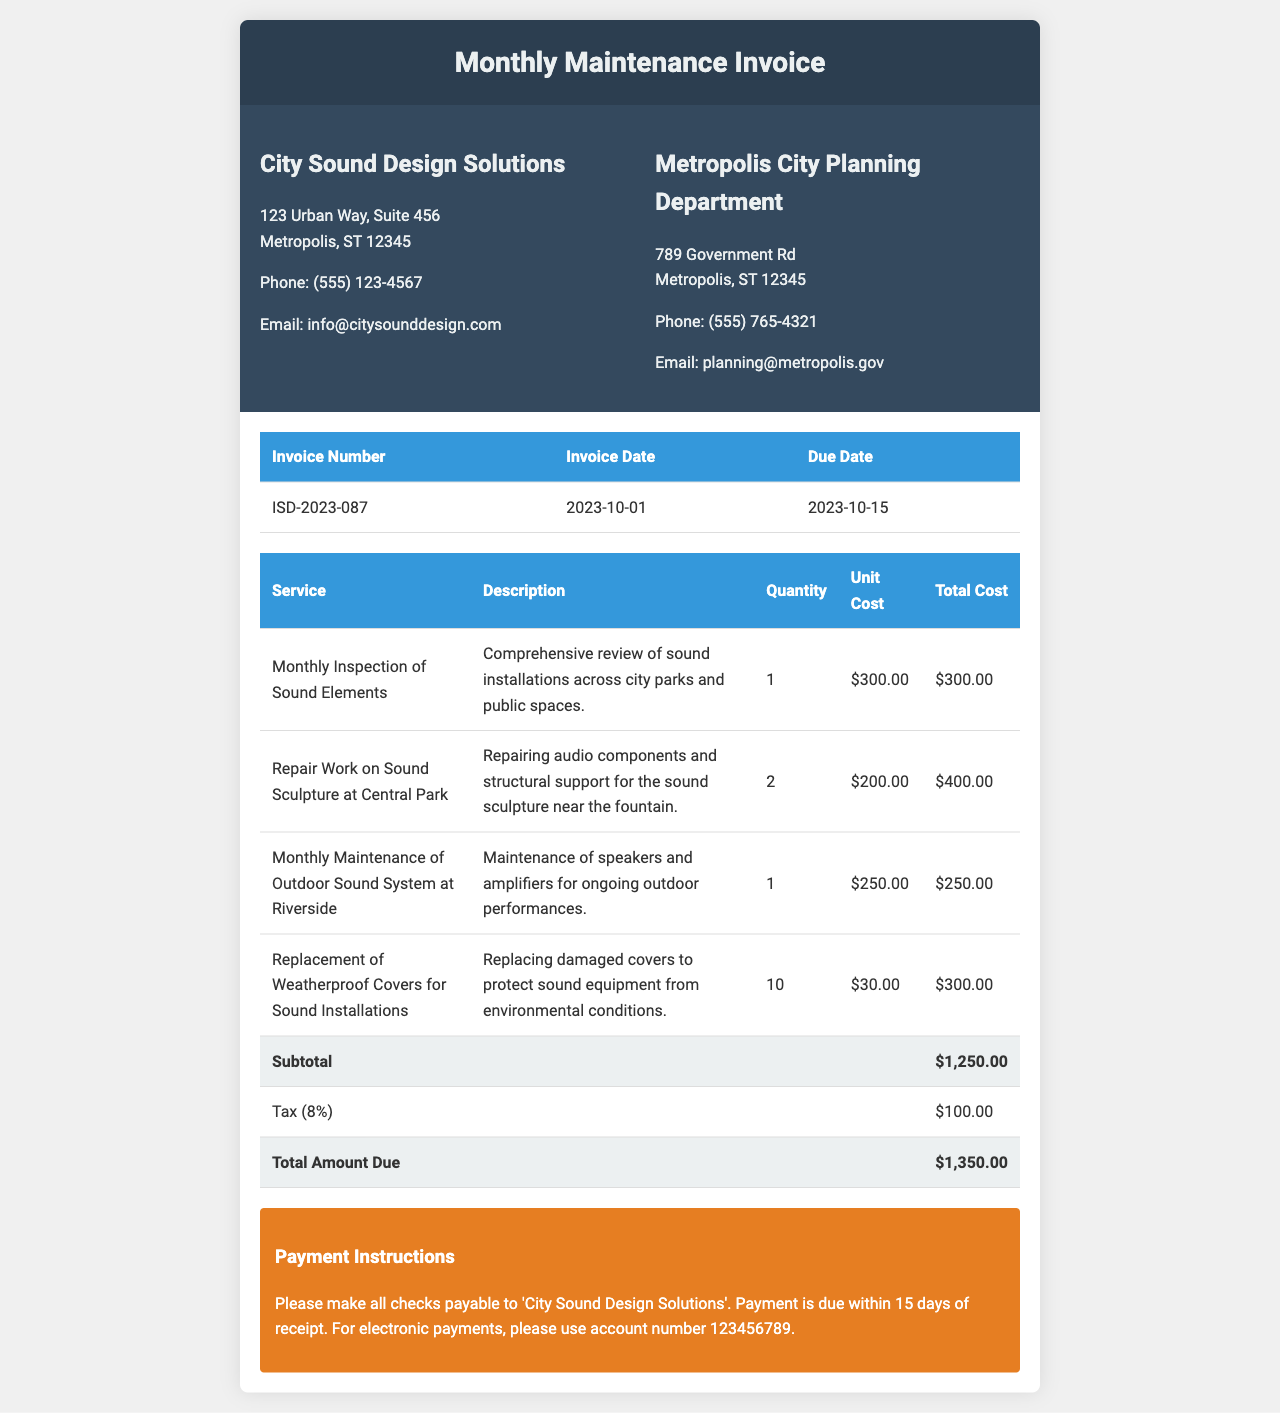What is the invoice number? The invoice number is provided in the document under the Invoice Details section.
Answer: ISD-2023-087 What is the total amount due? The total amount due can be found at the bottom of the invoice table in the Total Amount Due row.
Answer: $1,350.00 What is the due date for payment? The due date is mentioned under the Invoice Details section of the document.
Answer: 2023-10-15 How many weatherproof covers were replaced? The quantity for weatherproof covers is listed in the service table.
Answer: 10 What is the unit cost for the monthly inspection of sound elements? The unit cost can be found in the service table against the respective service description.
Answer: $300.00 How many services are listed in the invoice? The number of services can be determined by counting the rows in the service table, excluding the header.
Answer: 4 What is the tax percentage applied to the invoice? The tax percentage is noted in the service table under the tax line item.
Answer: 8% What sort of payment methods are accepted? The payment instructions section specifies accepted payment methods for the invoice.
Answer: Checks and electronic payments What company issued the invoice? The company name can be found in the invoice header.
Answer: City Sound Design Solutions 